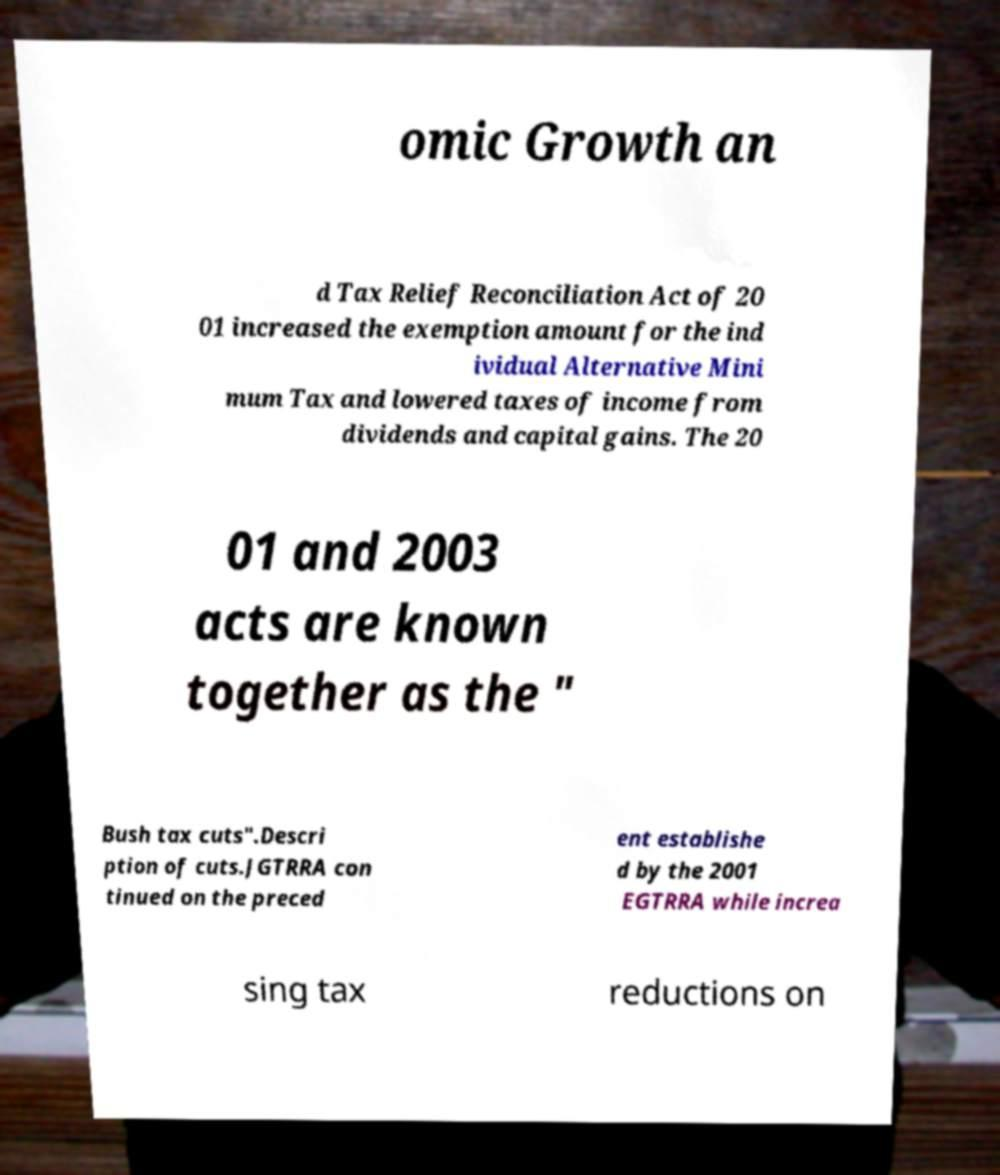Please identify and transcribe the text found in this image. omic Growth an d Tax Relief Reconciliation Act of 20 01 increased the exemption amount for the ind ividual Alternative Mini mum Tax and lowered taxes of income from dividends and capital gains. The 20 01 and 2003 acts are known together as the " Bush tax cuts".Descri ption of cuts.JGTRRA con tinued on the preced ent establishe d by the 2001 EGTRRA while increa sing tax reductions on 